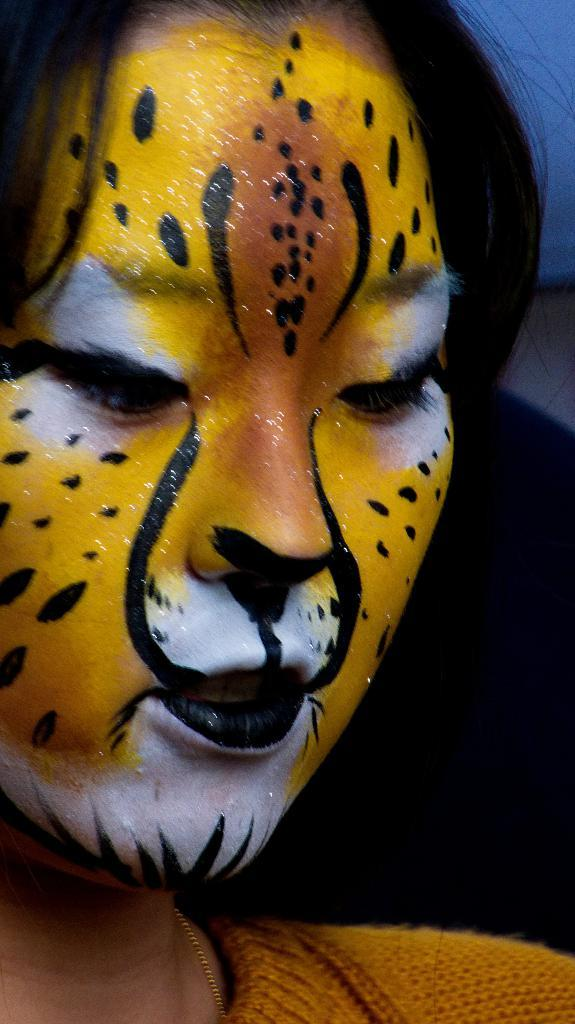What is on the woman's face in the image? There is a painting on the woman's face in the image. What type of vase is depicted in the painting on the woman's face? There is no vase depicted in the painting on the woman's face; the painting is not described in enough detail to identify any specific objects or elements. 